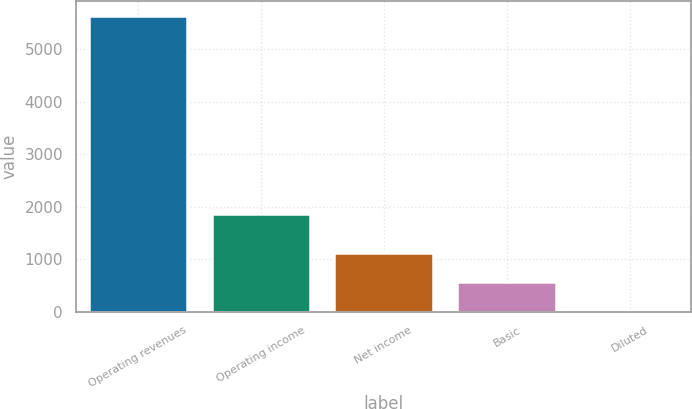Convert chart. <chart><loc_0><loc_0><loc_500><loc_500><bar_chart><fcel>Operating revenues<fcel>Operating income<fcel>Net income<fcel>Basic<fcel>Diluted<nl><fcel>5638<fcel>1854<fcel>1128.55<fcel>564.87<fcel>1.19<nl></chart> 